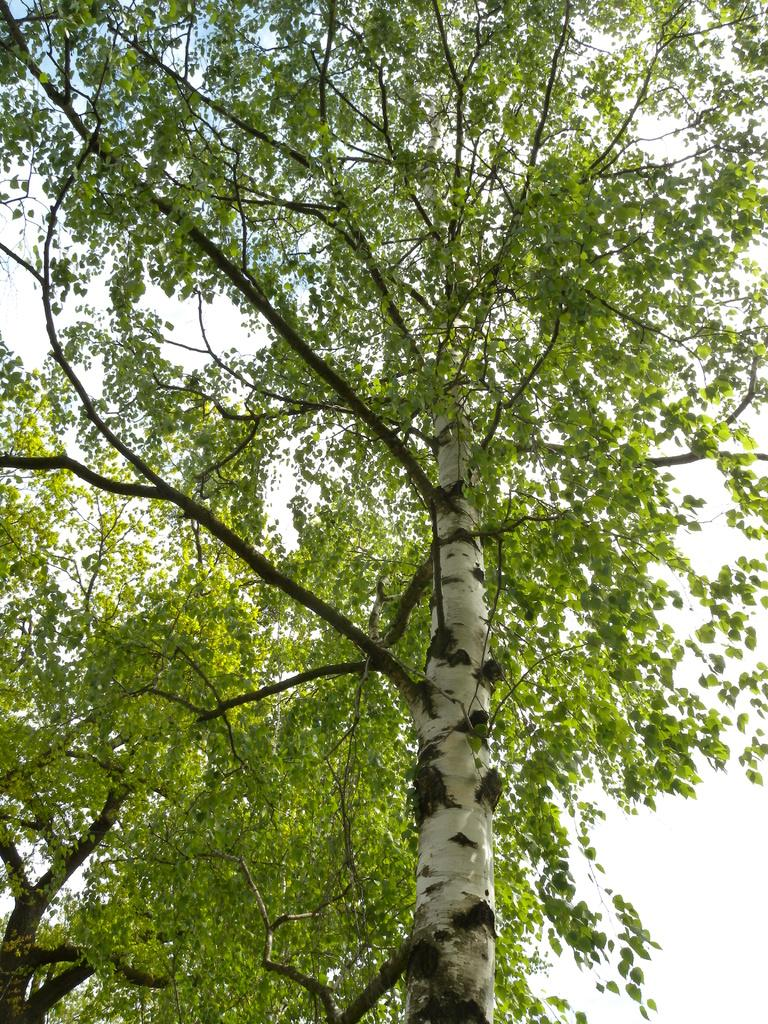What type of vegetation can be seen in the image? There are trees in the image. What part of the natural environment is visible in the image? The sky is visible in the image. What type of breakfast is being prepared in the image? There is no reference to breakfast or any food preparation in the image, as it only features trees and the sky. 